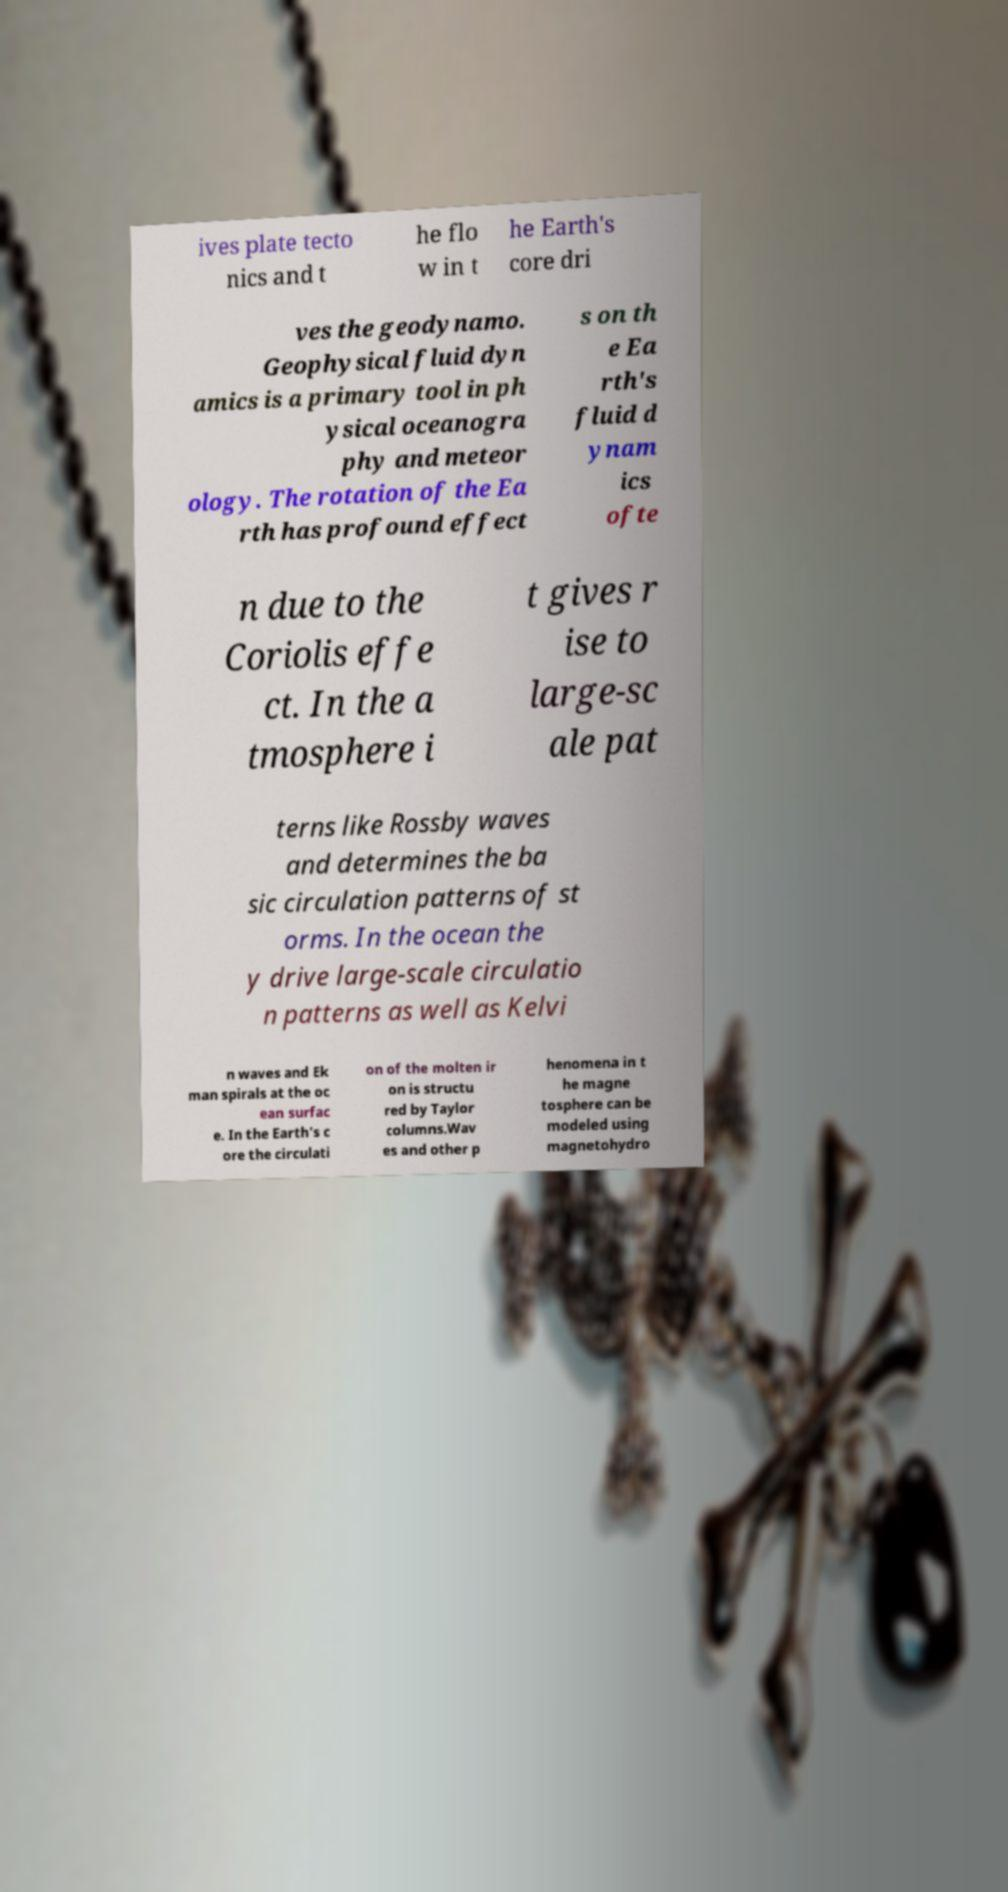Please identify and transcribe the text found in this image. ives plate tecto nics and t he flo w in t he Earth's core dri ves the geodynamo. Geophysical fluid dyn amics is a primary tool in ph ysical oceanogra phy and meteor ology. The rotation of the Ea rth has profound effect s on th e Ea rth's fluid d ynam ics ofte n due to the Coriolis effe ct. In the a tmosphere i t gives r ise to large-sc ale pat terns like Rossby waves and determines the ba sic circulation patterns of st orms. In the ocean the y drive large-scale circulatio n patterns as well as Kelvi n waves and Ek man spirals at the oc ean surfac e. In the Earth's c ore the circulati on of the molten ir on is structu red by Taylor columns.Wav es and other p henomena in t he magne tosphere can be modeled using magnetohydro 